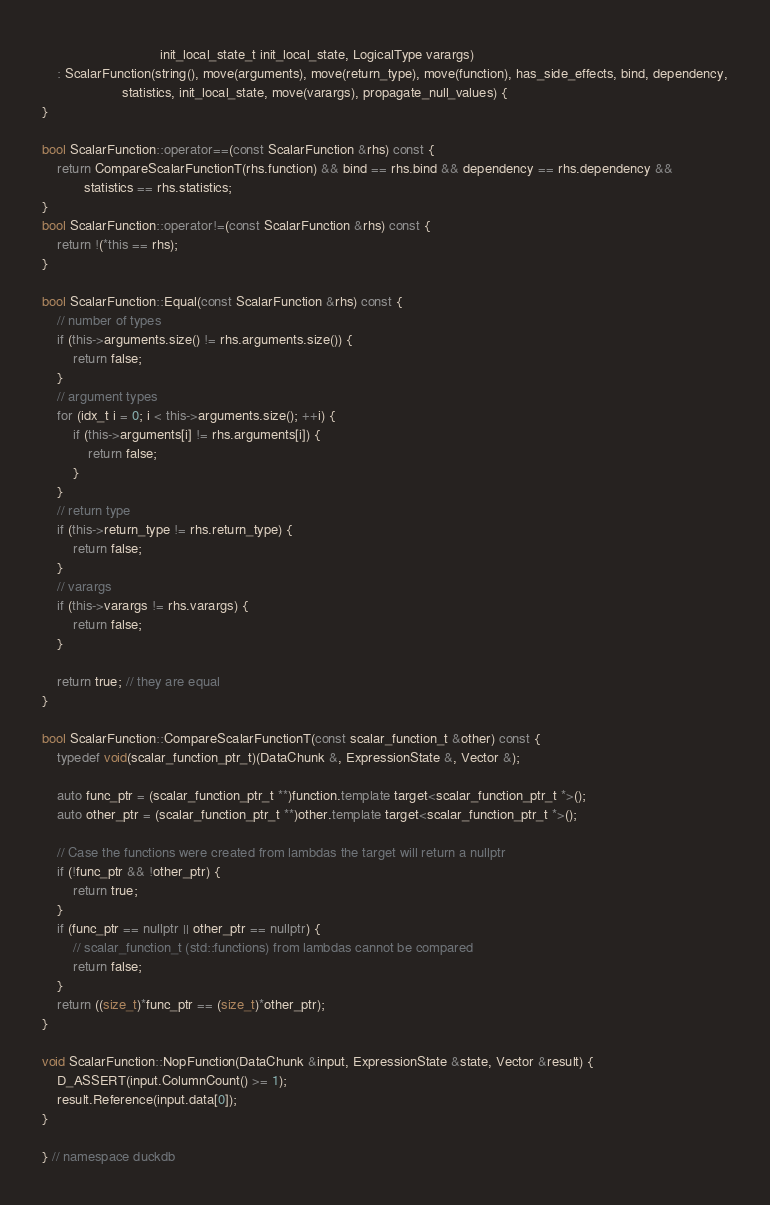<code> <loc_0><loc_0><loc_500><loc_500><_C++_>                               init_local_state_t init_local_state, LogicalType varargs)
    : ScalarFunction(string(), move(arguments), move(return_type), move(function), has_side_effects, bind, dependency,
                     statistics, init_local_state, move(varargs), propagate_null_values) {
}

bool ScalarFunction::operator==(const ScalarFunction &rhs) const {
	return CompareScalarFunctionT(rhs.function) && bind == rhs.bind && dependency == rhs.dependency &&
	       statistics == rhs.statistics;
}
bool ScalarFunction::operator!=(const ScalarFunction &rhs) const {
	return !(*this == rhs);
}

bool ScalarFunction::Equal(const ScalarFunction &rhs) const {
	// number of types
	if (this->arguments.size() != rhs.arguments.size()) {
		return false;
	}
	// argument types
	for (idx_t i = 0; i < this->arguments.size(); ++i) {
		if (this->arguments[i] != rhs.arguments[i]) {
			return false;
		}
	}
	// return type
	if (this->return_type != rhs.return_type) {
		return false;
	}
	// varargs
	if (this->varargs != rhs.varargs) {
		return false;
	}

	return true; // they are equal
}

bool ScalarFunction::CompareScalarFunctionT(const scalar_function_t &other) const {
	typedef void(scalar_function_ptr_t)(DataChunk &, ExpressionState &, Vector &);

	auto func_ptr = (scalar_function_ptr_t **)function.template target<scalar_function_ptr_t *>();
	auto other_ptr = (scalar_function_ptr_t **)other.template target<scalar_function_ptr_t *>();

	// Case the functions were created from lambdas the target will return a nullptr
	if (!func_ptr && !other_ptr) {
		return true;
	}
	if (func_ptr == nullptr || other_ptr == nullptr) {
		// scalar_function_t (std::functions) from lambdas cannot be compared
		return false;
	}
	return ((size_t)*func_ptr == (size_t)*other_ptr);
}

void ScalarFunction::NopFunction(DataChunk &input, ExpressionState &state, Vector &result) {
	D_ASSERT(input.ColumnCount() >= 1);
	result.Reference(input.data[0]);
}

} // namespace duckdb
</code> 